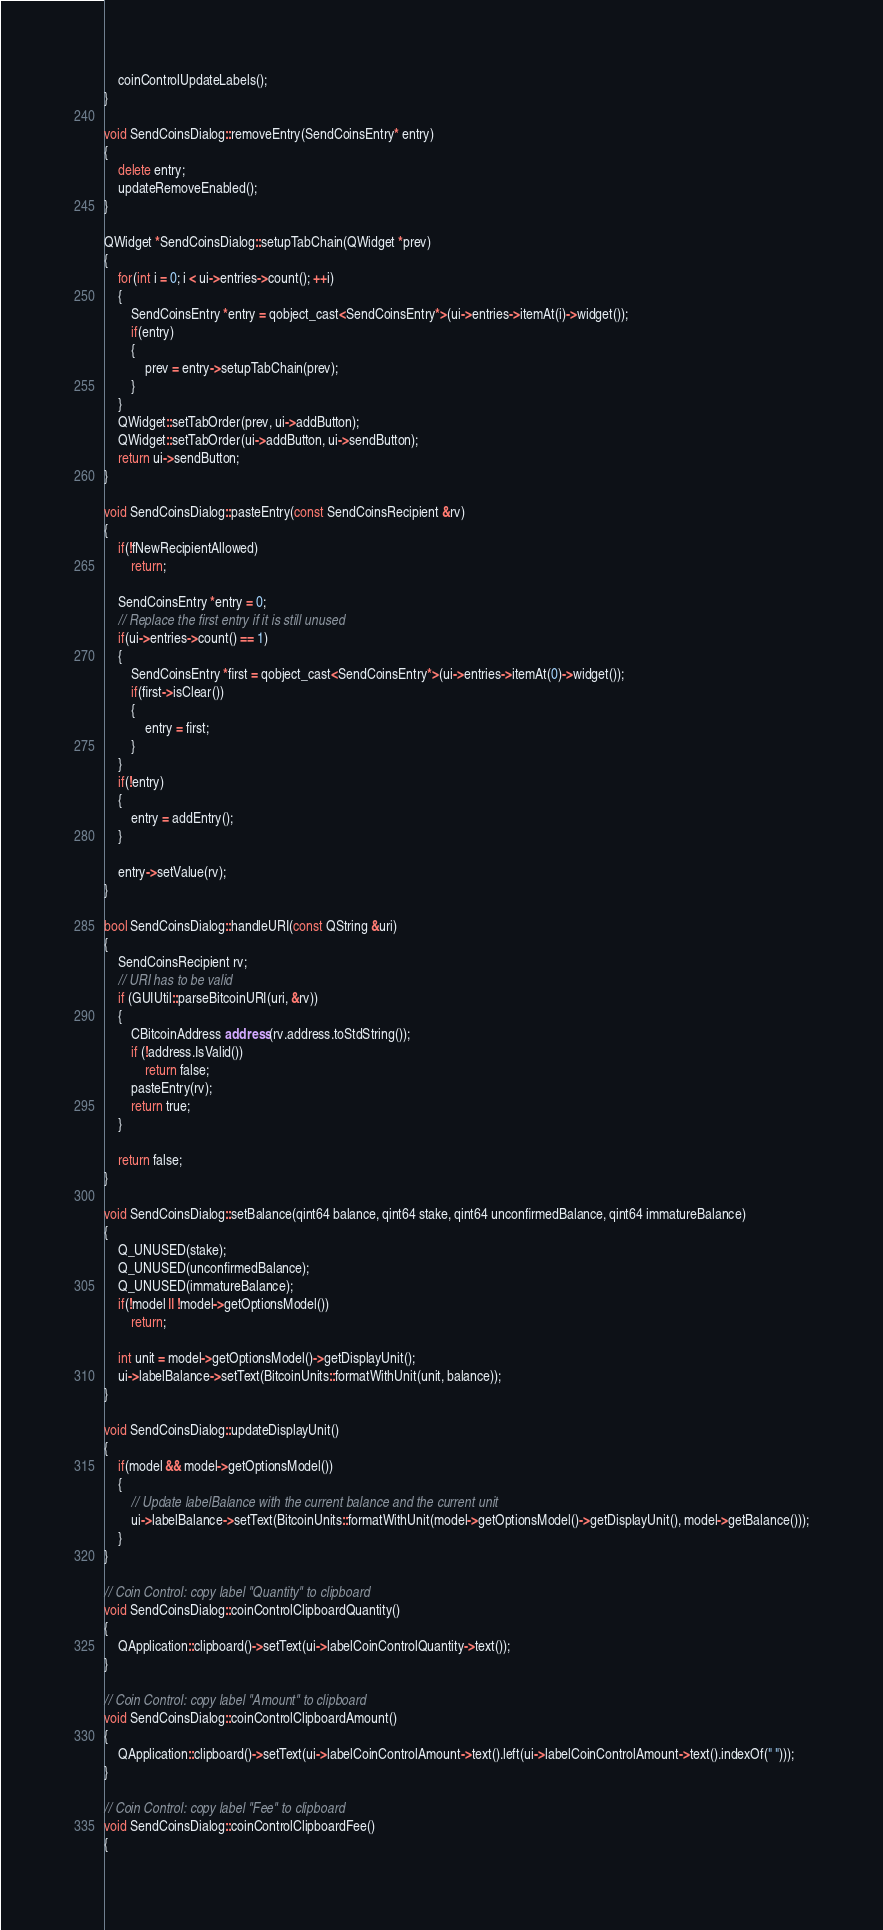<code> <loc_0><loc_0><loc_500><loc_500><_C++_>    coinControlUpdateLabels();
}

void SendCoinsDialog::removeEntry(SendCoinsEntry* entry)
{
    delete entry;
    updateRemoveEnabled();
}

QWidget *SendCoinsDialog::setupTabChain(QWidget *prev)
{
    for(int i = 0; i < ui->entries->count(); ++i)
    {
        SendCoinsEntry *entry = qobject_cast<SendCoinsEntry*>(ui->entries->itemAt(i)->widget());
        if(entry)
        {
            prev = entry->setupTabChain(prev);
        }
    }
    QWidget::setTabOrder(prev, ui->addButton);
    QWidget::setTabOrder(ui->addButton, ui->sendButton);
    return ui->sendButton;
}

void SendCoinsDialog::pasteEntry(const SendCoinsRecipient &rv)
{
    if(!fNewRecipientAllowed)
        return;

    SendCoinsEntry *entry = 0;
    // Replace the first entry if it is still unused
    if(ui->entries->count() == 1)
    {
        SendCoinsEntry *first = qobject_cast<SendCoinsEntry*>(ui->entries->itemAt(0)->widget());
        if(first->isClear())
        {
            entry = first;
        }
    }
    if(!entry)
    {
        entry = addEntry();
    }

    entry->setValue(rv);
}

bool SendCoinsDialog::handleURI(const QString &uri)
{
    SendCoinsRecipient rv;
    // URI has to be valid
    if (GUIUtil::parseBitcoinURI(uri, &rv))
    {
        CBitcoinAddress address(rv.address.toStdString());
        if (!address.IsValid())
            return false;
        pasteEntry(rv);
        return true;
    }

    return false;
}

void SendCoinsDialog::setBalance(qint64 balance, qint64 stake, qint64 unconfirmedBalance, qint64 immatureBalance)
{
    Q_UNUSED(stake);
    Q_UNUSED(unconfirmedBalance);
    Q_UNUSED(immatureBalance);
    if(!model || !model->getOptionsModel())
        return;

    int unit = model->getOptionsModel()->getDisplayUnit();
    ui->labelBalance->setText(BitcoinUnits::formatWithUnit(unit, balance));
}

void SendCoinsDialog::updateDisplayUnit()
{
    if(model && model->getOptionsModel())
    {
        // Update labelBalance with the current balance and the current unit
        ui->labelBalance->setText(BitcoinUnits::formatWithUnit(model->getOptionsModel()->getDisplayUnit(), model->getBalance()));
    }
}

// Coin Control: copy label "Quantity" to clipboard
void SendCoinsDialog::coinControlClipboardQuantity()
{
    QApplication::clipboard()->setText(ui->labelCoinControlQuantity->text());
}

// Coin Control: copy label "Amount" to clipboard
void SendCoinsDialog::coinControlClipboardAmount()
{
    QApplication::clipboard()->setText(ui->labelCoinControlAmount->text().left(ui->labelCoinControlAmount->text().indexOf(" ")));
}

// Coin Control: copy label "Fee" to clipboard
void SendCoinsDialog::coinControlClipboardFee()
{</code> 